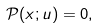<formula> <loc_0><loc_0><loc_500><loc_500>\mathcal { P } ( x ; u ) = 0 ,</formula> 